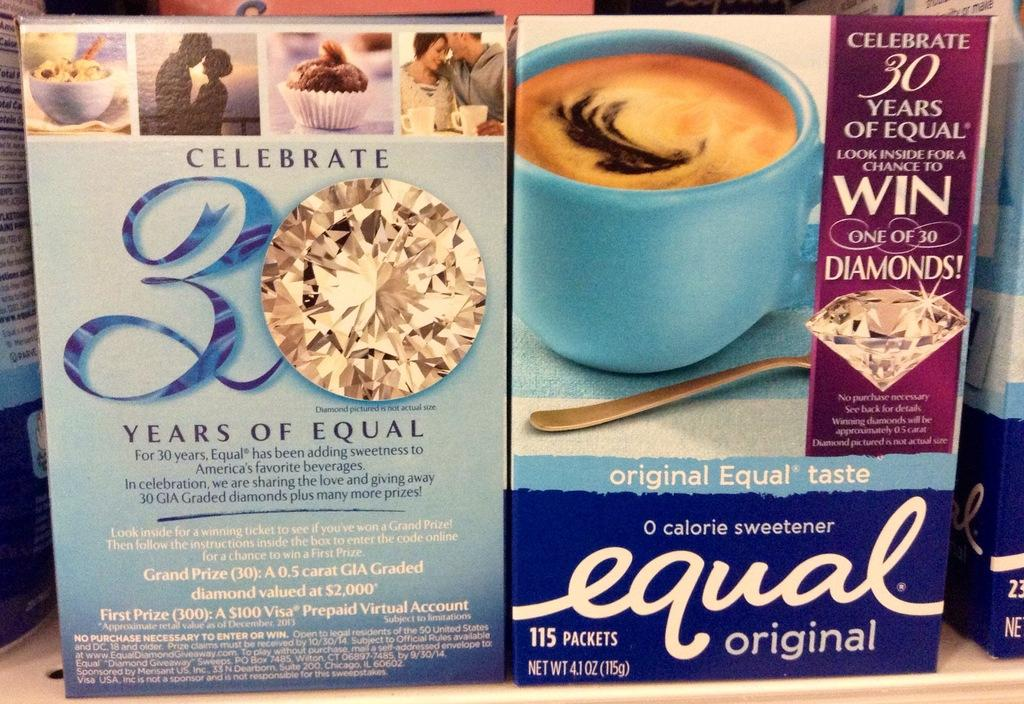<image>
Share a concise interpretation of the image provided. A box of Equal original includes 115 packets and has a photo of a blue mug. 